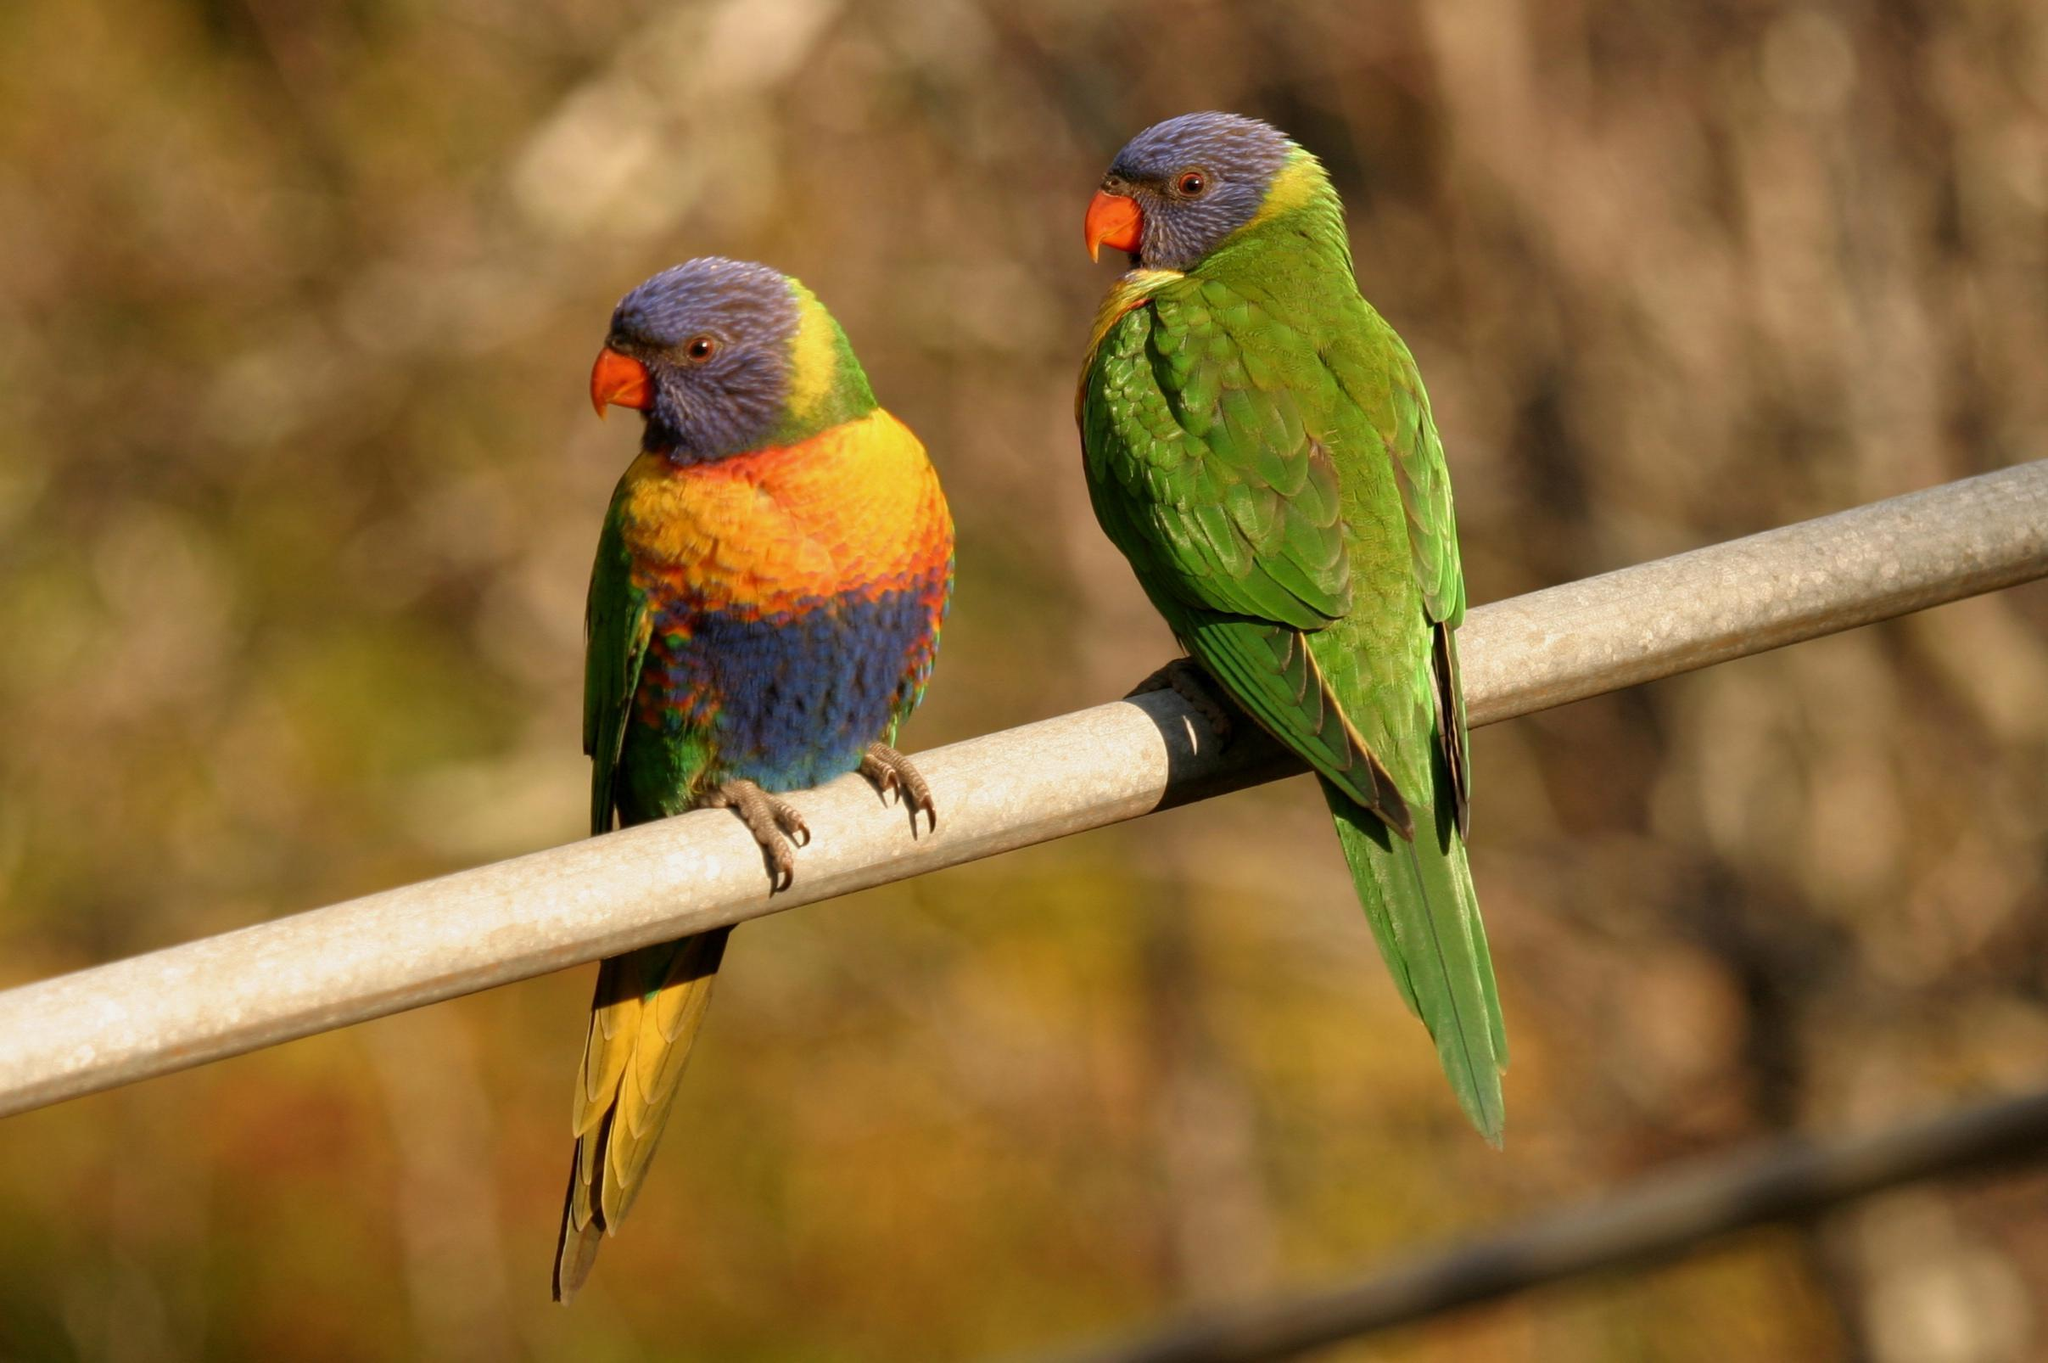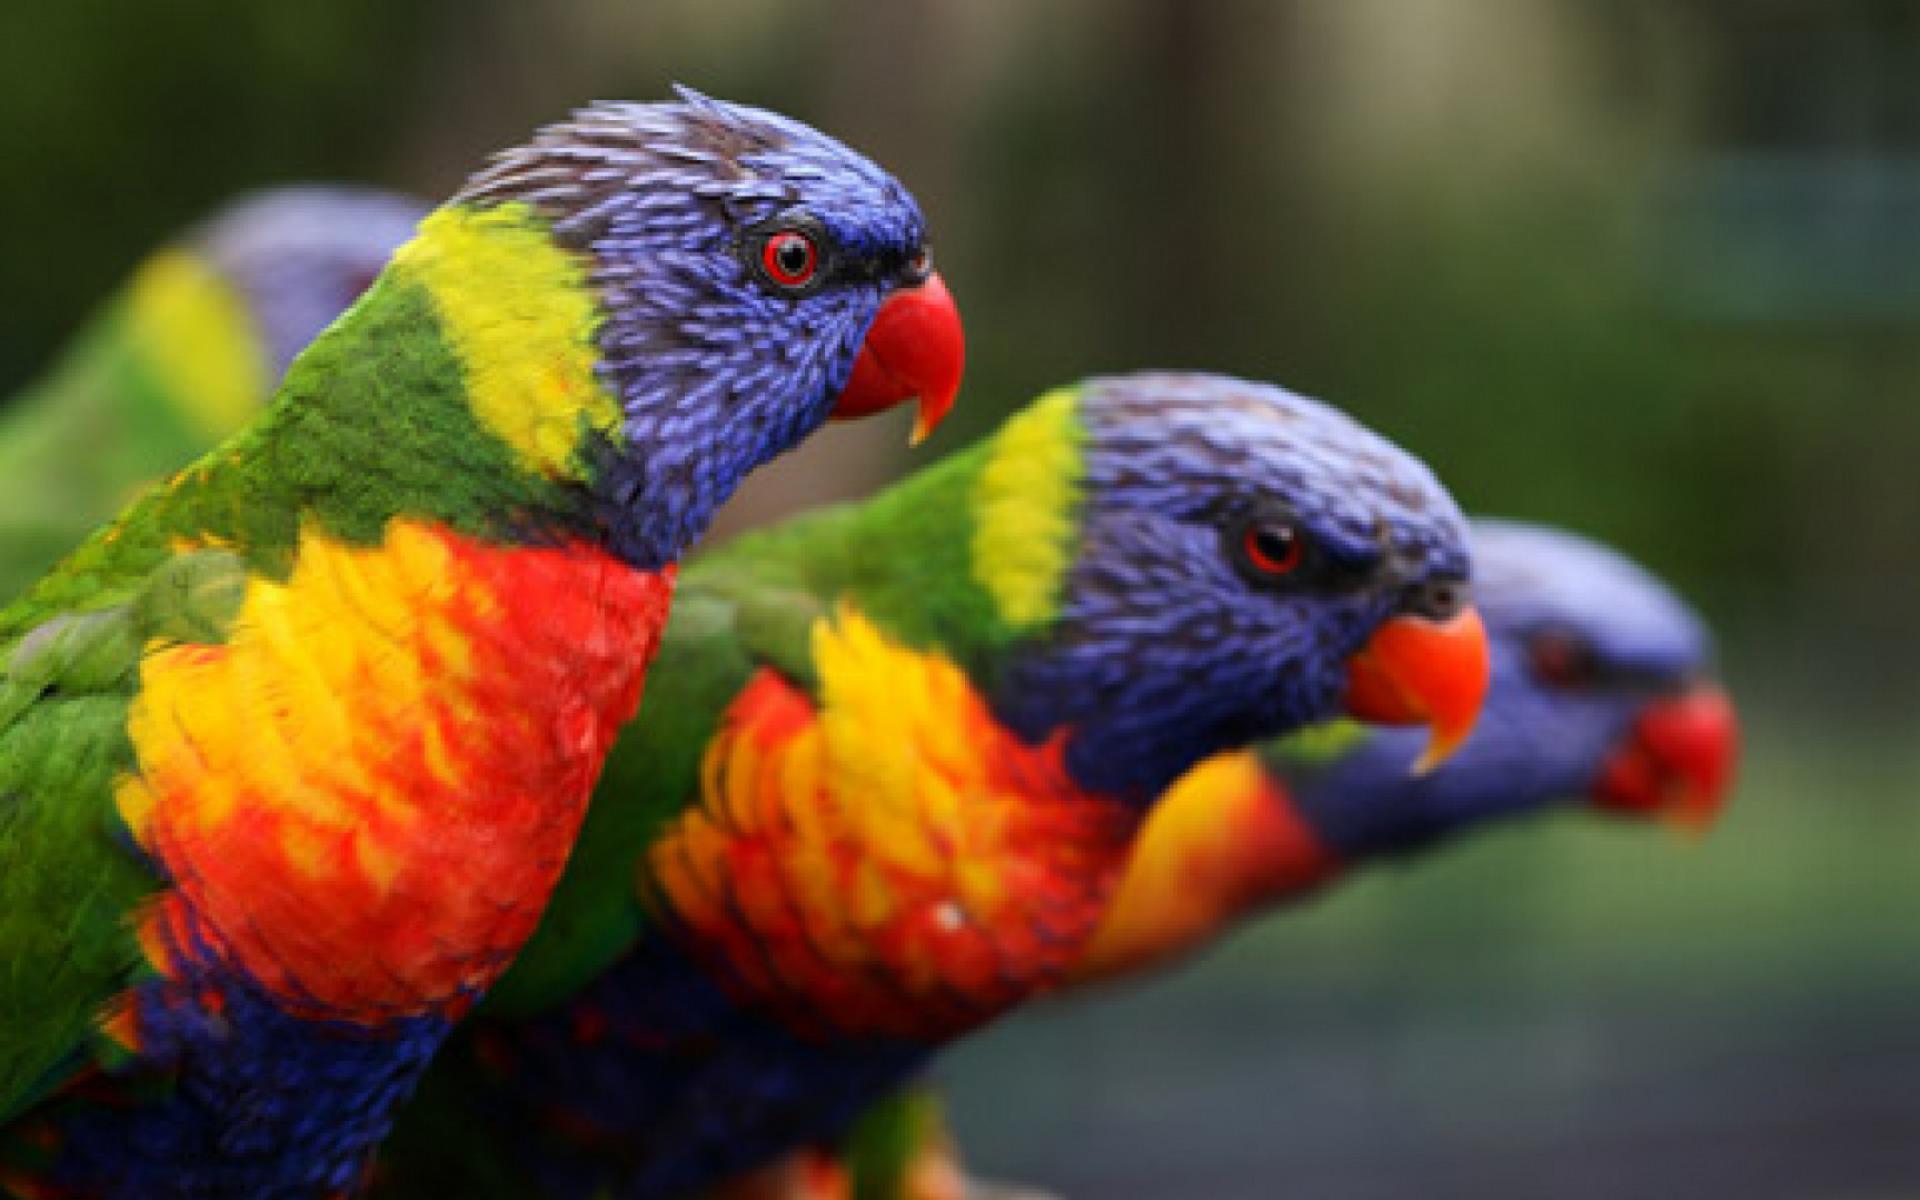The first image is the image on the left, the second image is the image on the right. For the images displayed, is the sentence "Two birds are perched together in at least one of the images." factually correct? Answer yes or no. Yes. The first image is the image on the left, the second image is the image on the right. Given the left and right images, does the statement "An image shows exactly one parrot perched upright on a real tree branch." hold true? Answer yes or no. No. 